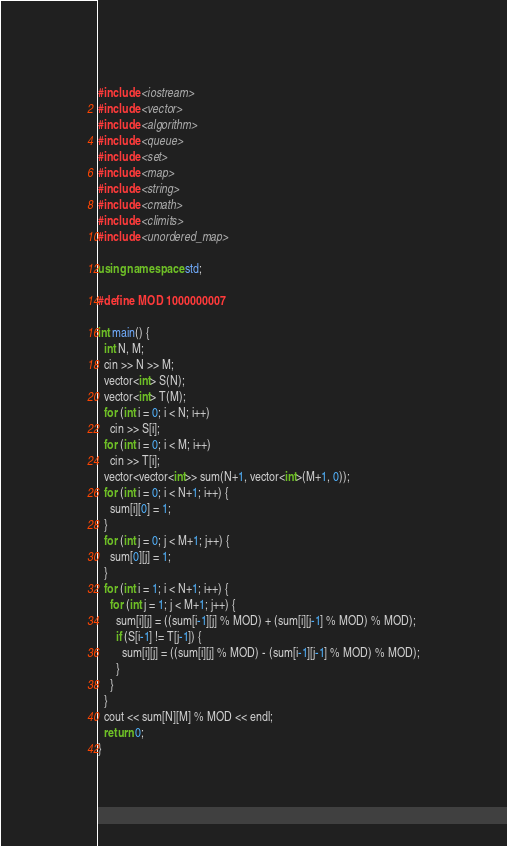<code> <loc_0><loc_0><loc_500><loc_500><_C++_>#include <iostream>
#include <vector>
#include <algorithm>
#include <queue>
#include <set>
#include <map>
#include <string>
#include <cmath>
#include <climits>
#include <unordered_map>

using namespace std;

#define MOD 1000000007

int main() {
  int N, M;
  cin >> N >> M;
  vector<int> S(N);
  vector<int> T(M);
  for (int i = 0; i < N; i++)
    cin >> S[i];
  for (int i = 0; i < M; i++)
    cin >> T[i];
  vector<vector<int>> sum(N+1, vector<int>(M+1, 0));
  for (int i = 0; i < N+1; i++) {
    sum[i][0] = 1;
  }
  for (int j = 0; j < M+1; j++) {
    sum[0][j] = 1;
  }
  for (int i = 1; i < N+1; i++) {
    for (int j = 1; j < M+1; j++) {
      sum[i][j] = ((sum[i-1][j] % MOD) + (sum[i][j-1] % MOD) % MOD);
      if (S[i-1] != T[j-1]) {
        sum[i][j] = ((sum[i][j] % MOD) - (sum[i-1][j-1] % MOD) % MOD);
      }
    }
  }
  cout << sum[N][M] % MOD << endl;
  return 0;
}
</code> 